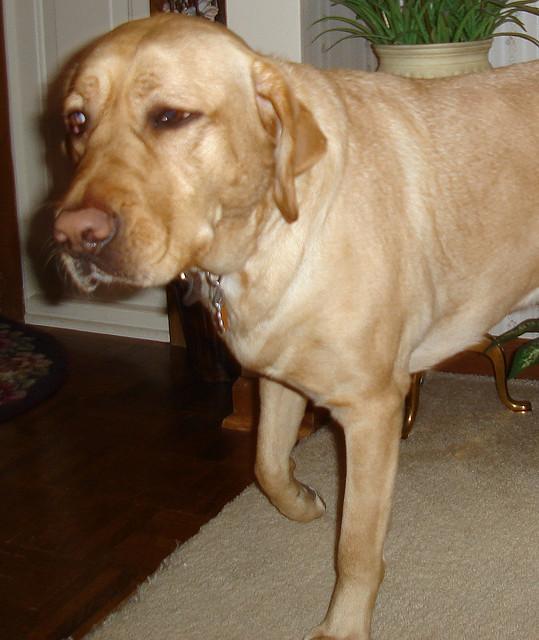What is the object behind the dog?
Short answer required. Plant. Is the dog wearing a collar?
Give a very brief answer. Yes. Is this a yellow lab?
Be succinct. Yes. 